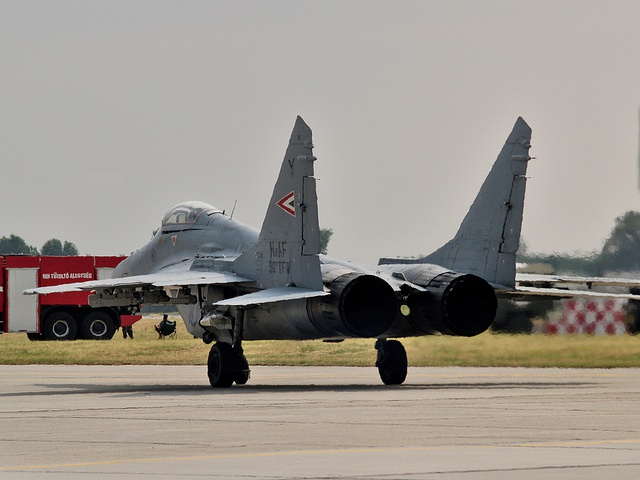Describe the objects in this image and their specific colors. I can see airplane in darkgray, gray, black, and purple tones, truck in darkgray, black, maroon, and gray tones, chair in darkgray, black, tan, olive, and gray tones, people in darkgray, black, gray, and maroon tones, and people in darkgray, black, tan, maroon, and gray tones in this image. 